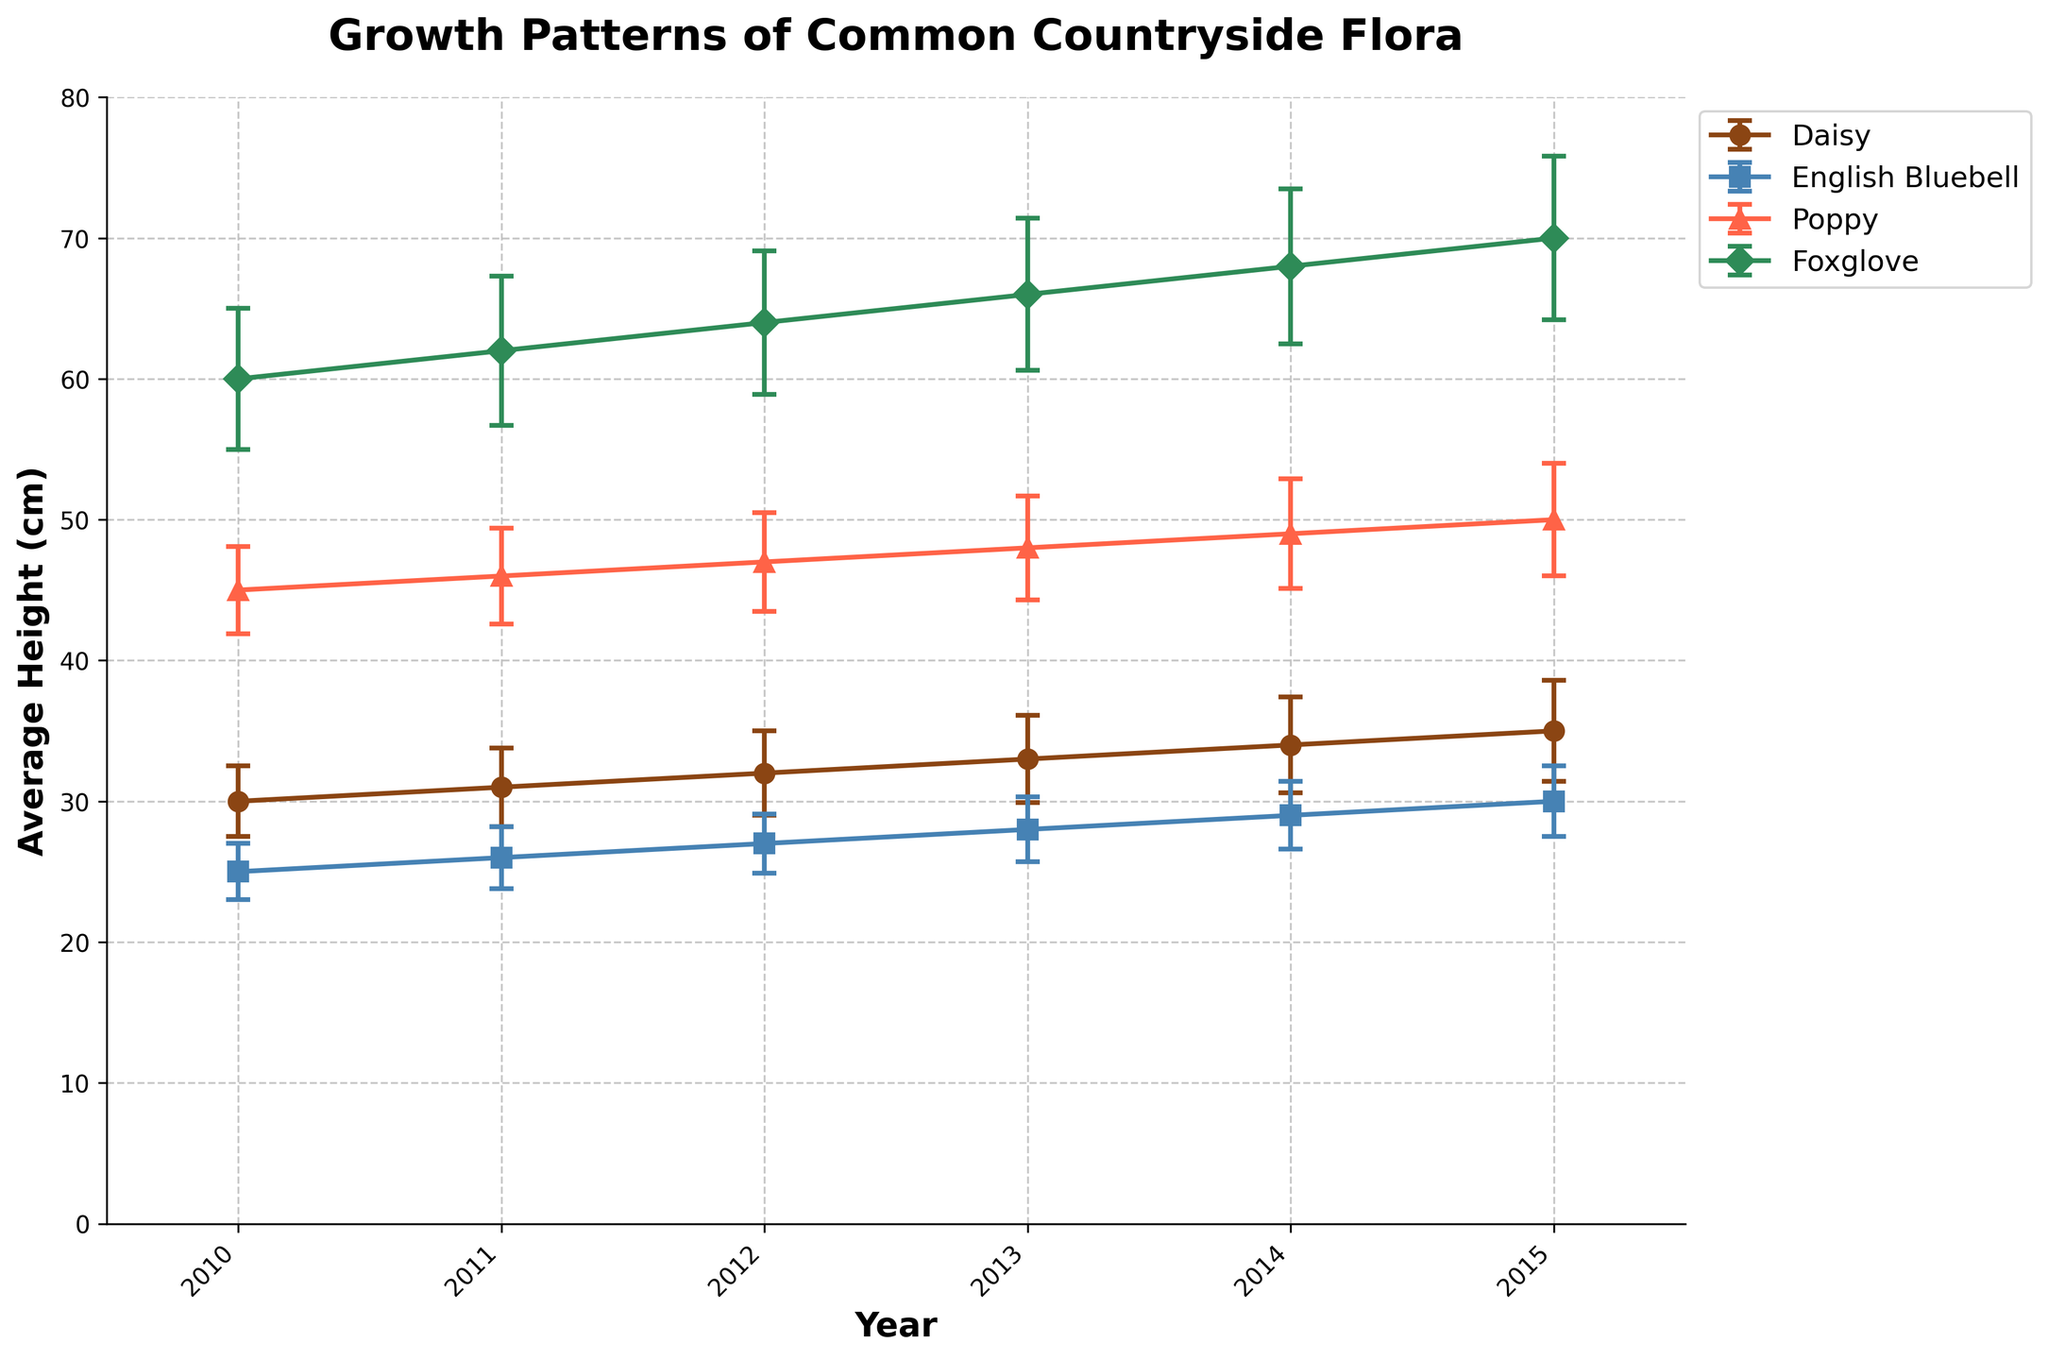what is the title of the plot? The title is displayed at the top of the figure in bold large text.
Answer: Growth Patterns of Common Countryside Flora What are the two axes labels in the graph? The x-axis label is usually found horizontally along the bottom of the plot, and the y-axis label is found vertically along the left side of the plot.
Answer: Year (x-axis), Average Height (cm) (y-axis) Which species has the tallest average height in 2015? Look at the data points in 2015 for each species and compare their heights. Foxglove has the tallest average height in 2015.
Answer: Foxglove Which species shows the most consistent growth (smallest error bars) over the years? Error bars represent the standard deviation. The species with the smallest error bars will have the least deviation in growth.
Answer: Daisy Between 2010 and 2015, which species had the largest increase in average height? Calculate the difference between the average height in 2015 and 2010 for each species, then compare. For Daisy, it’s 35 - 30 = 5 cm; for English Bluebell, it’s 30 - 25 = 5 cm; for Poppy, it’s 50 - 45 = 5 cm; for Foxglove, it’s 70 - 60 = 10 cm.
Answer: Foxglove In which year does Poppy reach an average height of 48 cm? Look along the x-axis for the year that the Poppy series reaches 48 cm on the y-axis.
Answer: 2013 Which two species have nearly equal average heights in 2015? Compare the average heights of each species in 2015. Daisy and English Bluebell both reach 35 and 30 cm respectively.
Answer: Daisy and English Bluebell Comparing Daisy and English Bluebell, which species has a higher growth rate over the span of 2010 to 2015? Calculate the difference in height from 2010 to 2015 for both species, then compare. For Daisy, it's 5 cm, and for English Bluebell, it's 5 cm. Thus, they are equal.
Answer: Daisy and English Bluebell have the same rate What is the average height of Poppy in 2012? Locate where the Poppy series intersects with the year 2012 on the x-axis.
Answer: 47 cm 